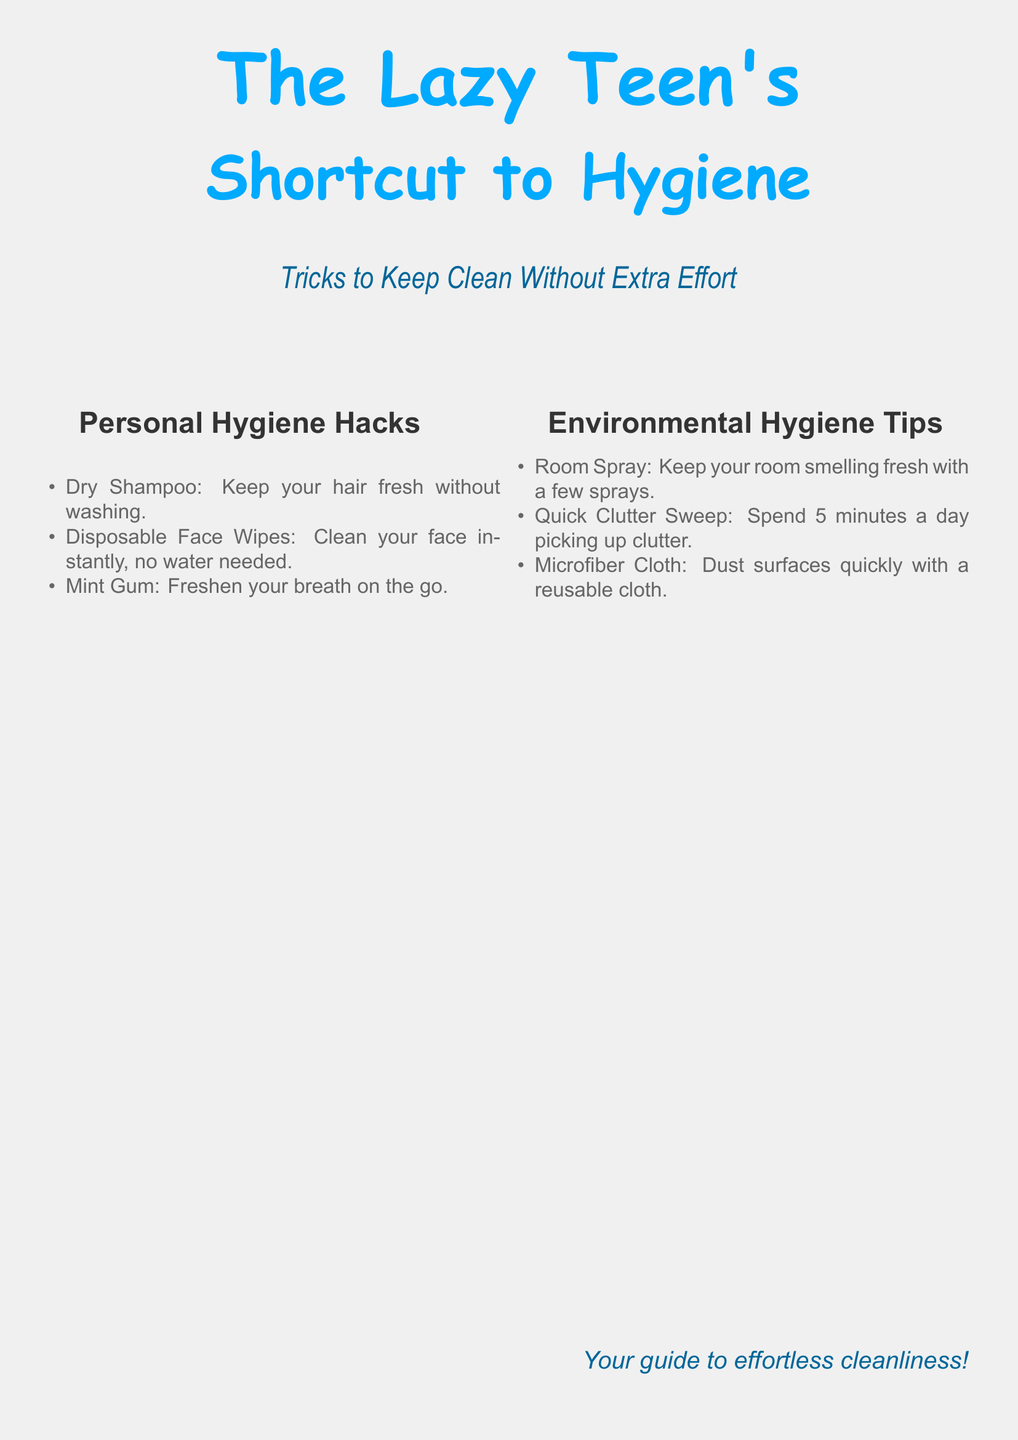What is the title of the book? The title of the book is presented prominently on the cover.
Answer: The Lazy Teen's Shortcut to Hygiene What is the subtitle of the book? The subtitle follows the title and provides a brief description of the content.
Answer: Tricks to Keep Clean Without Extra Effort What color is used for the title? The title is highlighted with a specific color mentioned in the document.
Answer: Blue How many personal hygiene hacks are listed? The number of items in the personal hygiene hacks section is counted.
Answer: Three What is one item listed under personal hygiene hacks? Any single item can be referenced from the provided list.
Answer: Dry Shampoo What is one tip for environmental hygiene? One specific tip is articulated in the environmental hygiene tips section.
Answer: Room Spray How is the document structured? The structure involves various sections categorized with specific headings.
Answer: Sections with headings Who is the target audience for this book? The title indicates that the book is aimed at a specific group.
Answer: Teens What is emphasized as the delivery style of the book? The subtitle suggests the manner in which cleanliness is addressed.
Answer: Effortless 